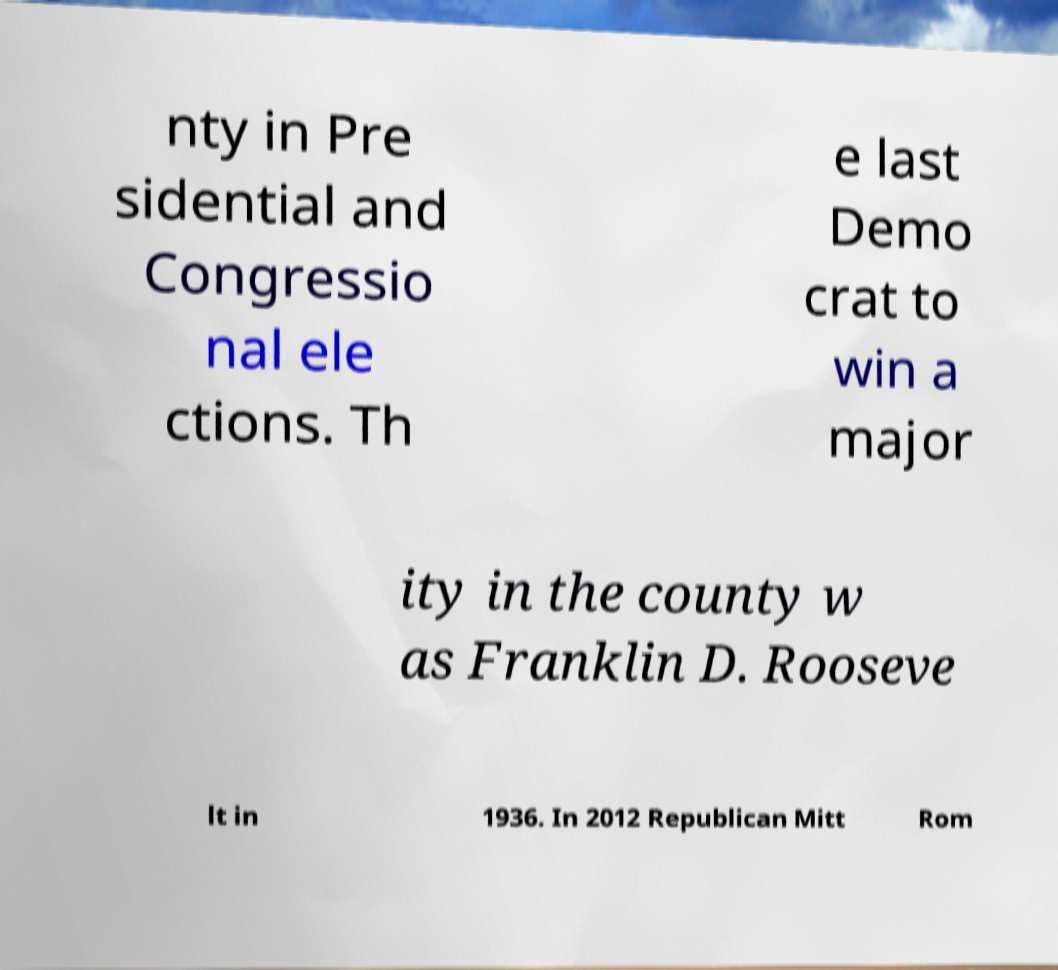What messages or text are displayed in this image? I need them in a readable, typed format. nty in Pre sidential and Congressio nal ele ctions. Th e last Demo crat to win a major ity in the county w as Franklin D. Rooseve lt in 1936. In 2012 Republican Mitt Rom 